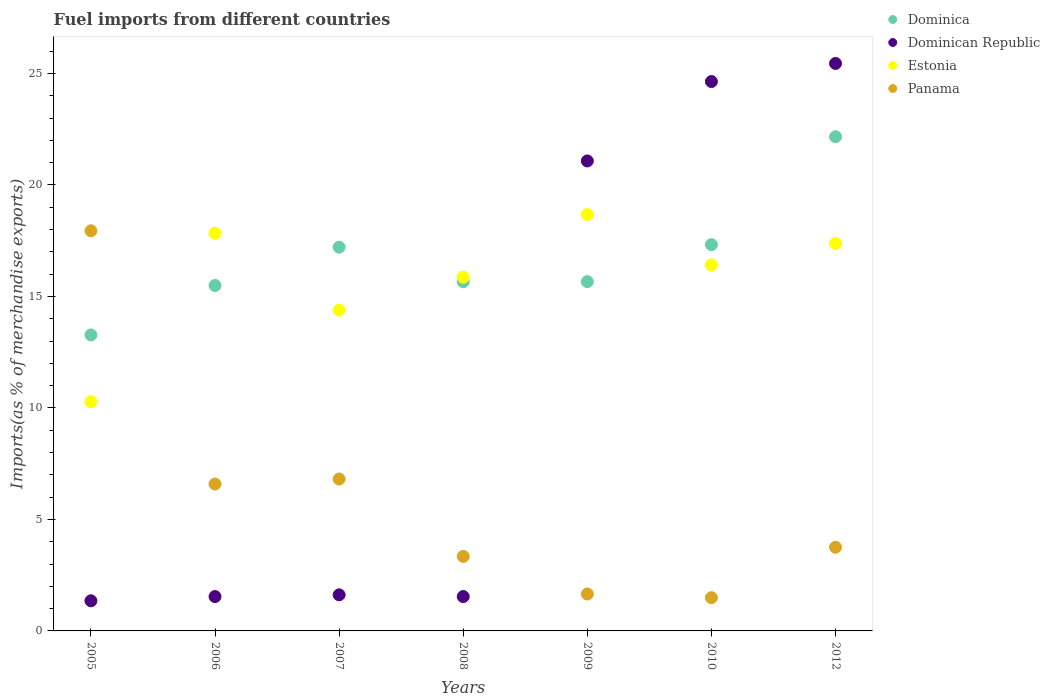How many different coloured dotlines are there?
Keep it short and to the point. 4. Is the number of dotlines equal to the number of legend labels?
Your answer should be very brief. Yes. What is the percentage of imports to different countries in Panama in 2008?
Your answer should be compact. 3.34. Across all years, what is the maximum percentage of imports to different countries in Dominican Republic?
Keep it short and to the point. 25.45. Across all years, what is the minimum percentage of imports to different countries in Panama?
Ensure brevity in your answer.  1.49. In which year was the percentage of imports to different countries in Dominica maximum?
Make the answer very short. 2012. What is the total percentage of imports to different countries in Panama in the graph?
Offer a terse response. 41.58. What is the difference between the percentage of imports to different countries in Dominican Republic in 2009 and that in 2012?
Offer a very short reply. -4.37. What is the difference between the percentage of imports to different countries in Dominica in 2006 and the percentage of imports to different countries in Estonia in 2008?
Your answer should be very brief. -0.37. What is the average percentage of imports to different countries in Estonia per year?
Provide a succinct answer. 15.83. In the year 2009, what is the difference between the percentage of imports to different countries in Panama and percentage of imports to different countries in Dominican Republic?
Your response must be concise. -19.42. In how many years, is the percentage of imports to different countries in Panama greater than 1 %?
Your answer should be compact. 7. What is the ratio of the percentage of imports to different countries in Panama in 2005 to that in 2009?
Offer a very short reply. 10.84. Is the percentage of imports to different countries in Estonia in 2009 less than that in 2012?
Offer a very short reply. No. What is the difference between the highest and the second highest percentage of imports to different countries in Dominican Republic?
Offer a very short reply. 0.81. What is the difference between the highest and the lowest percentage of imports to different countries in Dominican Republic?
Your response must be concise. 24.1. Is it the case that in every year, the sum of the percentage of imports to different countries in Dominica and percentage of imports to different countries in Panama  is greater than the percentage of imports to different countries in Estonia?
Keep it short and to the point. No. Is the percentage of imports to different countries in Estonia strictly greater than the percentage of imports to different countries in Dominican Republic over the years?
Make the answer very short. No. How many dotlines are there?
Provide a succinct answer. 4. How many years are there in the graph?
Your answer should be very brief. 7. What is the difference between two consecutive major ticks on the Y-axis?
Your answer should be very brief. 5. Does the graph contain any zero values?
Your response must be concise. No. Does the graph contain grids?
Your response must be concise. No. How are the legend labels stacked?
Provide a short and direct response. Vertical. What is the title of the graph?
Your response must be concise. Fuel imports from different countries. What is the label or title of the X-axis?
Provide a short and direct response. Years. What is the label or title of the Y-axis?
Your answer should be very brief. Imports(as % of merchandise exports). What is the Imports(as % of merchandise exports) in Dominica in 2005?
Offer a terse response. 13.27. What is the Imports(as % of merchandise exports) in Dominican Republic in 2005?
Offer a very short reply. 1.35. What is the Imports(as % of merchandise exports) in Estonia in 2005?
Make the answer very short. 10.28. What is the Imports(as % of merchandise exports) in Panama in 2005?
Your answer should be compact. 17.94. What is the Imports(as % of merchandise exports) in Dominica in 2006?
Ensure brevity in your answer.  15.49. What is the Imports(as % of merchandise exports) in Dominican Republic in 2006?
Provide a short and direct response. 1.54. What is the Imports(as % of merchandise exports) of Estonia in 2006?
Provide a succinct answer. 17.83. What is the Imports(as % of merchandise exports) in Panama in 2006?
Make the answer very short. 6.59. What is the Imports(as % of merchandise exports) in Dominica in 2007?
Make the answer very short. 17.21. What is the Imports(as % of merchandise exports) in Dominican Republic in 2007?
Your answer should be very brief. 1.62. What is the Imports(as % of merchandise exports) in Estonia in 2007?
Make the answer very short. 14.39. What is the Imports(as % of merchandise exports) in Panama in 2007?
Offer a very short reply. 6.81. What is the Imports(as % of merchandise exports) of Dominica in 2008?
Offer a terse response. 15.66. What is the Imports(as % of merchandise exports) in Dominican Republic in 2008?
Offer a terse response. 1.54. What is the Imports(as % of merchandise exports) in Estonia in 2008?
Provide a succinct answer. 15.86. What is the Imports(as % of merchandise exports) of Panama in 2008?
Offer a terse response. 3.34. What is the Imports(as % of merchandise exports) in Dominica in 2009?
Ensure brevity in your answer.  15.66. What is the Imports(as % of merchandise exports) in Dominican Republic in 2009?
Ensure brevity in your answer.  21.08. What is the Imports(as % of merchandise exports) in Estonia in 2009?
Provide a short and direct response. 18.67. What is the Imports(as % of merchandise exports) of Panama in 2009?
Give a very brief answer. 1.66. What is the Imports(as % of merchandise exports) of Dominica in 2010?
Your answer should be compact. 17.32. What is the Imports(as % of merchandise exports) of Dominican Republic in 2010?
Your answer should be very brief. 24.64. What is the Imports(as % of merchandise exports) of Estonia in 2010?
Provide a succinct answer. 16.41. What is the Imports(as % of merchandise exports) of Panama in 2010?
Provide a short and direct response. 1.49. What is the Imports(as % of merchandise exports) of Dominica in 2012?
Give a very brief answer. 22.16. What is the Imports(as % of merchandise exports) in Dominican Republic in 2012?
Your answer should be compact. 25.45. What is the Imports(as % of merchandise exports) in Estonia in 2012?
Give a very brief answer. 17.37. What is the Imports(as % of merchandise exports) in Panama in 2012?
Make the answer very short. 3.75. Across all years, what is the maximum Imports(as % of merchandise exports) of Dominica?
Keep it short and to the point. 22.16. Across all years, what is the maximum Imports(as % of merchandise exports) of Dominican Republic?
Your response must be concise. 25.45. Across all years, what is the maximum Imports(as % of merchandise exports) of Estonia?
Provide a succinct answer. 18.67. Across all years, what is the maximum Imports(as % of merchandise exports) in Panama?
Provide a short and direct response. 17.94. Across all years, what is the minimum Imports(as % of merchandise exports) in Dominica?
Make the answer very short. 13.27. Across all years, what is the minimum Imports(as % of merchandise exports) of Dominican Republic?
Offer a terse response. 1.35. Across all years, what is the minimum Imports(as % of merchandise exports) in Estonia?
Your answer should be compact. 10.28. Across all years, what is the minimum Imports(as % of merchandise exports) in Panama?
Offer a terse response. 1.49. What is the total Imports(as % of merchandise exports) in Dominica in the graph?
Give a very brief answer. 116.78. What is the total Imports(as % of merchandise exports) in Dominican Republic in the graph?
Ensure brevity in your answer.  77.21. What is the total Imports(as % of merchandise exports) of Estonia in the graph?
Your answer should be very brief. 110.82. What is the total Imports(as % of merchandise exports) of Panama in the graph?
Your answer should be compact. 41.58. What is the difference between the Imports(as % of merchandise exports) in Dominica in 2005 and that in 2006?
Provide a succinct answer. -2.22. What is the difference between the Imports(as % of merchandise exports) of Dominican Republic in 2005 and that in 2006?
Provide a succinct answer. -0.19. What is the difference between the Imports(as % of merchandise exports) in Estonia in 2005 and that in 2006?
Your answer should be very brief. -7.55. What is the difference between the Imports(as % of merchandise exports) of Panama in 2005 and that in 2006?
Your answer should be very brief. 11.36. What is the difference between the Imports(as % of merchandise exports) of Dominica in 2005 and that in 2007?
Provide a short and direct response. -3.93. What is the difference between the Imports(as % of merchandise exports) in Dominican Republic in 2005 and that in 2007?
Keep it short and to the point. -0.27. What is the difference between the Imports(as % of merchandise exports) in Estonia in 2005 and that in 2007?
Your response must be concise. -4.11. What is the difference between the Imports(as % of merchandise exports) in Panama in 2005 and that in 2007?
Your answer should be compact. 11.13. What is the difference between the Imports(as % of merchandise exports) of Dominica in 2005 and that in 2008?
Give a very brief answer. -2.39. What is the difference between the Imports(as % of merchandise exports) in Dominican Republic in 2005 and that in 2008?
Make the answer very short. -0.19. What is the difference between the Imports(as % of merchandise exports) of Estonia in 2005 and that in 2008?
Offer a terse response. -5.58. What is the difference between the Imports(as % of merchandise exports) in Panama in 2005 and that in 2008?
Your answer should be very brief. 14.6. What is the difference between the Imports(as % of merchandise exports) in Dominica in 2005 and that in 2009?
Your answer should be compact. -2.39. What is the difference between the Imports(as % of merchandise exports) of Dominican Republic in 2005 and that in 2009?
Give a very brief answer. -19.72. What is the difference between the Imports(as % of merchandise exports) of Estonia in 2005 and that in 2009?
Provide a short and direct response. -8.39. What is the difference between the Imports(as % of merchandise exports) in Panama in 2005 and that in 2009?
Offer a very short reply. 16.29. What is the difference between the Imports(as % of merchandise exports) of Dominica in 2005 and that in 2010?
Provide a succinct answer. -4.05. What is the difference between the Imports(as % of merchandise exports) in Dominican Republic in 2005 and that in 2010?
Provide a succinct answer. -23.28. What is the difference between the Imports(as % of merchandise exports) of Estonia in 2005 and that in 2010?
Make the answer very short. -6.13. What is the difference between the Imports(as % of merchandise exports) of Panama in 2005 and that in 2010?
Offer a terse response. 16.45. What is the difference between the Imports(as % of merchandise exports) in Dominica in 2005 and that in 2012?
Your response must be concise. -8.89. What is the difference between the Imports(as % of merchandise exports) in Dominican Republic in 2005 and that in 2012?
Make the answer very short. -24.1. What is the difference between the Imports(as % of merchandise exports) of Estonia in 2005 and that in 2012?
Give a very brief answer. -7.09. What is the difference between the Imports(as % of merchandise exports) in Panama in 2005 and that in 2012?
Provide a short and direct response. 14.19. What is the difference between the Imports(as % of merchandise exports) in Dominica in 2006 and that in 2007?
Provide a succinct answer. -1.72. What is the difference between the Imports(as % of merchandise exports) in Dominican Republic in 2006 and that in 2007?
Make the answer very short. -0.08. What is the difference between the Imports(as % of merchandise exports) of Estonia in 2006 and that in 2007?
Keep it short and to the point. 3.45. What is the difference between the Imports(as % of merchandise exports) of Panama in 2006 and that in 2007?
Provide a short and direct response. -0.23. What is the difference between the Imports(as % of merchandise exports) in Dominica in 2006 and that in 2008?
Provide a short and direct response. -0.17. What is the difference between the Imports(as % of merchandise exports) of Dominican Republic in 2006 and that in 2008?
Provide a succinct answer. -0. What is the difference between the Imports(as % of merchandise exports) of Estonia in 2006 and that in 2008?
Provide a short and direct response. 1.97. What is the difference between the Imports(as % of merchandise exports) in Panama in 2006 and that in 2008?
Your answer should be compact. 3.25. What is the difference between the Imports(as % of merchandise exports) in Dominica in 2006 and that in 2009?
Ensure brevity in your answer.  -0.17. What is the difference between the Imports(as % of merchandise exports) in Dominican Republic in 2006 and that in 2009?
Provide a short and direct response. -19.53. What is the difference between the Imports(as % of merchandise exports) in Estonia in 2006 and that in 2009?
Ensure brevity in your answer.  -0.84. What is the difference between the Imports(as % of merchandise exports) of Panama in 2006 and that in 2009?
Make the answer very short. 4.93. What is the difference between the Imports(as % of merchandise exports) of Dominica in 2006 and that in 2010?
Offer a very short reply. -1.83. What is the difference between the Imports(as % of merchandise exports) in Dominican Republic in 2006 and that in 2010?
Offer a terse response. -23.09. What is the difference between the Imports(as % of merchandise exports) in Estonia in 2006 and that in 2010?
Provide a succinct answer. 1.42. What is the difference between the Imports(as % of merchandise exports) in Panama in 2006 and that in 2010?
Give a very brief answer. 5.1. What is the difference between the Imports(as % of merchandise exports) in Dominica in 2006 and that in 2012?
Ensure brevity in your answer.  -6.67. What is the difference between the Imports(as % of merchandise exports) in Dominican Republic in 2006 and that in 2012?
Offer a very short reply. -23.91. What is the difference between the Imports(as % of merchandise exports) in Estonia in 2006 and that in 2012?
Keep it short and to the point. 0.46. What is the difference between the Imports(as % of merchandise exports) of Panama in 2006 and that in 2012?
Make the answer very short. 2.84. What is the difference between the Imports(as % of merchandise exports) of Dominica in 2007 and that in 2008?
Ensure brevity in your answer.  1.55. What is the difference between the Imports(as % of merchandise exports) of Dominican Republic in 2007 and that in 2008?
Your answer should be very brief. 0.08. What is the difference between the Imports(as % of merchandise exports) of Estonia in 2007 and that in 2008?
Make the answer very short. -1.48. What is the difference between the Imports(as % of merchandise exports) in Panama in 2007 and that in 2008?
Ensure brevity in your answer.  3.47. What is the difference between the Imports(as % of merchandise exports) in Dominica in 2007 and that in 2009?
Provide a short and direct response. 1.54. What is the difference between the Imports(as % of merchandise exports) in Dominican Republic in 2007 and that in 2009?
Give a very brief answer. -19.46. What is the difference between the Imports(as % of merchandise exports) in Estonia in 2007 and that in 2009?
Offer a terse response. -4.29. What is the difference between the Imports(as % of merchandise exports) of Panama in 2007 and that in 2009?
Make the answer very short. 5.16. What is the difference between the Imports(as % of merchandise exports) of Dominica in 2007 and that in 2010?
Your answer should be compact. -0.11. What is the difference between the Imports(as % of merchandise exports) of Dominican Republic in 2007 and that in 2010?
Make the answer very short. -23.02. What is the difference between the Imports(as % of merchandise exports) in Estonia in 2007 and that in 2010?
Your answer should be very brief. -2.03. What is the difference between the Imports(as % of merchandise exports) in Panama in 2007 and that in 2010?
Provide a short and direct response. 5.32. What is the difference between the Imports(as % of merchandise exports) of Dominica in 2007 and that in 2012?
Your answer should be compact. -4.95. What is the difference between the Imports(as % of merchandise exports) of Dominican Republic in 2007 and that in 2012?
Your answer should be compact. -23.83. What is the difference between the Imports(as % of merchandise exports) of Estonia in 2007 and that in 2012?
Offer a very short reply. -2.98. What is the difference between the Imports(as % of merchandise exports) of Panama in 2007 and that in 2012?
Make the answer very short. 3.06. What is the difference between the Imports(as % of merchandise exports) of Dominica in 2008 and that in 2009?
Provide a succinct answer. -0. What is the difference between the Imports(as % of merchandise exports) in Dominican Republic in 2008 and that in 2009?
Your answer should be compact. -19.53. What is the difference between the Imports(as % of merchandise exports) in Estonia in 2008 and that in 2009?
Your answer should be compact. -2.81. What is the difference between the Imports(as % of merchandise exports) in Panama in 2008 and that in 2009?
Offer a very short reply. 1.69. What is the difference between the Imports(as % of merchandise exports) in Dominica in 2008 and that in 2010?
Offer a very short reply. -1.66. What is the difference between the Imports(as % of merchandise exports) of Dominican Republic in 2008 and that in 2010?
Provide a succinct answer. -23.09. What is the difference between the Imports(as % of merchandise exports) in Estonia in 2008 and that in 2010?
Your response must be concise. -0.55. What is the difference between the Imports(as % of merchandise exports) in Panama in 2008 and that in 2010?
Provide a succinct answer. 1.85. What is the difference between the Imports(as % of merchandise exports) of Dominica in 2008 and that in 2012?
Provide a succinct answer. -6.5. What is the difference between the Imports(as % of merchandise exports) of Dominican Republic in 2008 and that in 2012?
Offer a very short reply. -23.91. What is the difference between the Imports(as % of merchandise exports) of Estonia in 2008 and that in 2012?
Provide a short and direct response. -1.51. What is the difference between the Imports(as % of merchandise exports) of Panama in 2008 and that in 2012?
Your answer should be compact. -0.41. What is the difference between the Imports(as % of merchandise exports) in Dominica in 2009 and that in 2010?
Keep it short and to the point. -1.66. What is the difference between the Imports(as % of merchandise exports) of Dominican Republic in 2009 and that in 2010?
Make the answer very short. -3.56. What is the difference between the Imports(as % of merchandise exports) of Estonia in 2009 and that in 2010?
Your answer should be compact. 2.26. What is the difference between the Imports(as % of merchandise exports) in Panama in 2009 and that in 2010?
Ensure brevity in your answer.  0.16. What is the difference between the Imports(as % of merchandise exports) of Dominica in 2009 and that in 2012?
Provide a succinct answer. -6.5. What is the difference between the Imports(as % of merchandise exports) of Dominican Republic in 2009 and that in 2012?
Your answer should be compact. -4.37. What is the difference between the Imports(as % of merchandise exports) in Estonia in 2009 and that in 2012?
Ensure brevity in your answer.  1.3. What is the difference between the Imports(as % of merchandise exports) of Panama in 2009 and that in 2012?
Ensure brevity in your answer.  -2.1. What is the difference between the Imports(as % of merchandise exports) in Dominica in 2010 and that in 2012?
Make the answer very short. -4.84. What is the difference between the Imports(as % of merchandise exports) in Dominican Republic in 2010 and that in 2012?
Ensure brevity in your answer.  -0.81. What is the difference between the Imports(as % of merchandise exports) of Estonia in 2010 and that in 2012?
Make the answer very short. -0.96. What is the difference between the Imports(as % of merchandise exports) of Panama in 2010 and that in 2012?
Your answer should be compact. -2.26. What is the difference between the Imports(as % of merchandise exports) of Dominica in 2005 and the Imports(as % of merchandise exports) of Dominican Republic in 2006?
Offer a terse response. 11.73. What is the difference between the Imports(as % of merchandise exports) in Dominica in 2005 and the Imports(as % of merchandise exports) in Estonia in 2006?
Your answer should be compact. -4.56. What is the difference between the Imports(as % of merchandise exports) in Dominica in 2005 and the Imports(as % of merchandise exports) in Panama in 2006?
Keep it short and to the point. 6.69. What is the difference between the Imports(as % of merchandise exports) of Dominican Republic in 2005 and the Imports(as % of merchandise exports) of Estonia in 2006?
Ensure brevity in your answer.  -16.48. What is the difference between the Imports(as % of merchandise exports) in Dominican Republic in 2005 and the Imports(as % of merchandise exports) in Panama in 2006?
Your answer should be very brief. -5.24. What is the difference between the Imports(as % of merchandise exports) in Estonia in 2005 and the Imports(as % of merchandise exports) in Panama in 2006?
Offer a very short reply. 3.69. What is the difference between the Imports(as % of merchandise exports) of Dominica in 2005 and the Imports(as % of merchandise exports) of Dominican Republic in 2007?
Your answer should be very brief. 11.65. What is the difference between the Imports(as % of merchandise exports) of Dominica in 2005 and the Imports(as % of merchandise exports) of Estonia in 2007?
Keep it short and to the point. -1.11. What is the difference between the Imports(as % of merchandise exports) of Dominica in 2005 and the Imports(as % of merchandise exports) of Panama in 2007?
Make the answer very short. 6.46. What is the difference between the Imports(as % of merchandise exports) of Dominican Republic in 2005 and the Imports(as % of merchandise exports) of Estonia in 2007?
Provide a succinct answer. -13.04. What is the difference between the Imports(as % of merchandise exports) of Dominican Republic in 2005 and the Imports(as % of merchandise exports) of Panama in 2007?
Offer a very short reply. -5.46. What is the difference between the Imports(as % of merchandise exports) of Estonia in 2005 and the Imports(as % of merchandise exports) of Panama in 2007?
Provide a succinct answer. 3.47. What is the difference between the Imports(as % of merchandise exports) of Dominica in 2005 and the Imports(as % of merchandise exports) of Dominican Republic in 2008?
Provide a short and direct response. 11.73. What is the difference between the Imports(as % of merchandise exports) in Dominica in 2005 and the Imports(as % of merchandise exports) in Estonia in 2008?
Your response must be concise. -2.59. What is the difference between the Imports(as % of merchandise exports) in Dominica in 2005 and the Imports(as % of merchandise exports) in Panama in 2008?
Ensure brevity in your answer.  9.93. What is the difference between the Imports(as % of merchandise exports) in Dominican Republic in 2005 and the Imports(as % of merchandise exports) in Estonia in 2008?
Make the answer very short. -14.51. What is the difference between the Imports(as % of merchandise exports) in Dominican Republic in 2005 and the Imports(as % of merchandise exports) in Panama in 2008?
Your response must be concise. -1.99. What is the difference between the Imports(as % of merchandise exports) of Estonia in 2005 and the Imports(as % of merchandise exports) of Panama in 2008?
Provide a succinct answer. 6.94. What is the difference between the Imports(as % of merchandise exports) in Dominica in 2005 and the Imports(as % of merchandise exports) in Dominican Republic in 2009?
Provide a short and direct response. -7.8. What is the difference between the Imports(as % of merchandise exports) in Dominica in 2005 and the Imports(as % of merchandise exports) in Estonia in 2009?
Give a very brief answer. -5.4. What is the difference between the Imports(as % of merchandise exports) in Dominica in 2005 and the Imports(as % of merchandise exports) in Panama in 2009?
Your answer should be compact. 11.62. What is the difference between the Imports(as % of merchandise exports) in Dominican Republic in 2005 and the Imports(as % of merchandise exports) in Estonia in 2009?
Your answer should be compact. -17.32. What is the difference between the Imports(as % of merchandise exports) of Dominican Republic in 2005 and the Imports(as % of merchandise exports) of Panama in 2009?
Your response must be concise. -0.3. What is the difference between the Imports(as % of merchandise exports) of Estonia in 2005 and the Imports(as % of merchandise exports) of Panama in 2009?
Provide a succinct answer. 8.63. What is the difference between the Imports(as % of merchandise exports) of Dominica in 2005 and the Imports(as % of merchandise exports) of Dominican Republic in 2010?
Ensure brevity in your answer.  -11.36. What is the difference between the Imports(as % of merchandise exports) in Dominica in 2005 and the Imports(as % of merchandise exports) in Estonia in 2010?
Provide a short and direct response. -3.14. What is the difference between the Imports(as % of merchandise exports) of Dominica in 2005 and the Imports(as % of merchandise exports) of Panama in 2010?
Provide a succinct answer. 11.78. What is the difference between the Imports(as % of merchandise exports) in Dominican Republic in 2005 and the Imports(as % of merchandise exports) in Estonia in 2010?
Ensure brevity in your answer.  -15.06. What is the difference between the Imports(as % of merchandise exports) in Dominican Republic in 2005 and the Imports(as % of merchandise exports) in Panama in 2010?
Provide a succinct answer. -0.14. What is the difference between the Imports(as % of merchandise exports) in Estonia in 2005 and the Imports(as % of merchandise exports) in Panama in 2010?
Give a very brief answer. 8.79. What is the difference between the Imports(as % of merchandise exports) in Dominica in 2005 and the Imports(as % of merchandise exports) in Dominican Republic in 2012?
Offer a terse response. -12.17. What is the difference between the Imports(as % of merchandise exports) of Dominica in 2005 and the Imports(as % of merchandise exports) of Estonia in 2012?
Keep it short and to the point. -4.1. What is the difference between the Imports(as % of merchandise exports) in Dominica in 2005 and the Imports(as % of merchandise exports) in Panama in 2012?
Your response must be concise. 9.52. What is the difference between the Imports(as % of merchandise exports) in Dominican Republic in 2005 and the Imports(as % of merchandise exports) in Estonia in 2012?
Your answer should be very brief. -16.02. What is the difference between the Imports(as % of merchandise exports) of Dominican Republic in 2005 and the Imports(as % of merchandise exports) of Panama in 2012?
Provide a short and direct response. -2.4. What is the difference between the Imports(as % of merchandise exports) in Estonia in 2005 and the Imports(as % of merchandise exports) in Panama in 2012?
Keep it short and to the point. 6.53. What is the difference between the Imports(as % of merchandise exports) of Dominica in 2006 and the Imports(as % of merchandise exports) of Dominican Republic in 2007?
Provide a succinct answer. 13.87. What is the difference between the Imports(as % of merchandise exports) of Dominica in 2006 and the Imports(as % of merchandise exports) of Estonia in 2007?
Ensure brevity in your answer.  1.1. What is the difference between the Imports(as % of merchandise exports) of Dominica in 2006 and the Imports(as % of merchandise exports) of Panama in 2007?
Your answer should be compact. 8.68. What is the difference between the Imports(as % of merchandise exports) of Dominican Republic in 2006 and the Imports(as % of merchandise exports) of Estonia in 2007?
Ensure brevity in your answer.  -12.85. What is the difference between the Imports(as % of merchandise exports) in Dominican Republic in 2006 and the Imports(as % of merchandise exports) in Panama in 2007?
Keep it short and to the point. -5.27. What is the difference between the Imports(as % of merchandise exports) of Estonia in 2006 and the Imports(as % of merchandise exports) of Panama in 2007?
Give a very brief answer. 11.02. What is the difference between the Imports(as % of merchandise exports) in Dominica in 2006 and the Imports(as % of merchandise exports) in Dominican Republic in 2008?
Your response must be concise. 13.95. What is the difference between the Imports(as % of merchandise exports) in Dominica in 2006 and the Imports(as % of merchandise exports) in Estonia in 2008?
Your answer should be compact. -0.37. What is the difference between the Imports(as % of merchandise exports) of Dominica in 2006 and the Imports(as % of merchandise exports) of Panama in 2008?
Your answer should be very brief. 12.15. What is the difference between the Imports(as % of merchandise exports) in Dominican Republic in 2006 and the Imports(as % of merchandise exports) in Estonia in 2008?
Give a very brief answer. -14.32. What is the difference between the Imports(as % of merchandise exports) in Dominican Republic in 2006 and the Imports(as % of merchandise exports) in Panama in 2008?
Give a very brief answer. -1.8. What is the difference between the Imports(as % of merchandise exports) in Estonia in 2006 and the Imports(as % of merchandise exports) in Panama in 2008?
Your answer should be compact. 14.49. What is the difference between the Imports(as % of merchandise exports) in Dominica in 2006 and the Imports(as % of merchandise exports) in Dominican Republic in 2009?
Provide a succinct answer. -5.59. What is the difference between the Imports(as % of merchandise exports) of Dominica in 2006 and the Imports(as % of merchandise exports) of Estonia in 2009?
Offer a terse response. -3.18. What is the difference between the Imports(as % of merchandise exports) in Dominica in 2006 and the Imports(as % of merchandise exports) in Panama in 2009?
Offer a very short reply. 13.83. What is the difference between the Imports(as % of merchandise exports) in Dominican Republic in 2006 and the Imports(as % of merchandise exports) in Estonia in 2009?
Give a very brief answer. -17.13. What is the difference between the Imports(as % of merchandise exports) in Dominican Republic in 2006 and the Imports(as % of merchandise exports) in Panama in 2009?
Your answer should be very brief. -0.12. What is the difference between the Imports(as % of merchandise exports) in Estonia in 2006 and the Imports(as % of merchandise exports) in Panama in 2009?
Keep it short and to the point. 16.18. What is the difference between the Imports(as % of merchandise exports) in Dominica in 2006 and the Imports(as % of merchandise exports) in Dominican Republic in 2010?
Provide a succinct answer. -9.15. What is the difference between the Imports(as % of merchandise exports) of Dominica in 2006 and the Imports(as % of merchandise exports) of Estonia in 2010?
Keep it short and to the point. -0.92. What is the difference between the Imports(as % of merchandise exports) of Dominica in 2006 and the Imports(as % of merchandise exports) of Panama in 2010?
Make the answer very short. 14. What is the difference between the Imports(as % of merchandise exports) of Dominican Republic in 2006 and the Imports(as % of merchandise exports) of Estonia in 2010?
Keep it short and to the point. -14.87. What is the difference between the Imports(as % of merchandise exports) in Dominican Republic in 2006 and the Imports(as % of merchandise exports) in Panama in 2010?
Your response must be concise. 0.05. What is the difference between the Imports(as % of merchandise exports) of Estonia in 2006 and the Imports(as % of merchandise exports) of Panama in 2010?
Your answer should be compact. 16.34. What is the difference between the Imports(as % of merchandise exports) of Dominica in 2006 and the Imports(as % of merchandise exports) of Dominican Republic in 2012?
Your answer should be very brief. -9.96. What is the difference between the Imports(as % of merchandise exports) of Dominica in 2006 and the Imports(as % of merchandise exports) of Estonia in 2012?
Offer a very short reply. -1.88. What is the difference between the Imports(as % of merchandise exports) of Dominica in 2006 and the Imports(as % of merchandise exports) of Panama in 2012?
Ensure brevity in your answer.  11.74. What is the difference between the Imports(as % of merchandise exports) in Dominican Republic in 2006 and the Imports(as % of merchandise exports) in Estonia in 2012?
Make the answer very short. -15.83. What is the difference between the Imports(as % of merchandise exports) of Dominican Republic in 2006 and the Imports(as % of merchandise exports) of Panama in 2012?
Offer a terse response. -2.21. What is the difference between the Imports(as % of merchandise exports) in Estonia in 2006 and the Imports(as % of merchandise exports) in Panama in 2012?
Ensure brevity in your answer.  14.08. What is the difference between the Imports(as % of merchandise exports) of Dominica in 2007 and the Imports(as % of merchandise exports) of Dominican Republic in 2008?
Provide a short and direct response. 15.67. What is the difference between the Imports(as % of merchandise exports) in Dominica in 2007 and the Imports(as % of merchandise exports) in Estonia in 2008?
Make the answer very short. 1.35. What is the difference between the Imports(as % of merchandise exports) in Dominica in 2007 and the Imports(as % of merchandise exports) in Panama in 2008?
Give a very brief answer. 13.87. What is the difference between the Imports(as % of merchandise exports) of Dominican Republic in 2007 and the Imports(as % of merchandise exports) of Estonia in 2008?
Your answer should be very brief. -14.24. What is the difference between the Imports(as % of merchandise exports) of Dominican Republic in 2007 and the Imports(as % of merchandise exports) of Panama in 2008?
Provide a succinct answer. -1.72. What is the difference between the Imports(as % of merchandise exports) in Estonia in 2007 and the Imports(as % of merchandise exports) in Panama in 2008?
Offer a very short reply. 11.05. What is the difference between the Imports(as % of merchandise exports) in Dominica in 2007 and the Imports(as % of merchandise exports) in Dominican Republic in 2009?
Provide a short and direct response. -3.87. What is the difference between the Imports(as % of merchandise exports) of Dominica in 2007 and the Imports(as % of merchandise exports) of Estonia in 2009?
Your answer should be very brief. -1.47. What is the difference between the Imports(as % of merchandise exports) of Dominica in 2007 and the Imports(as % of merchandise exports) of Panama in 2009?
Your answer should be very brief. 15.55. What is the difference between the Imports(as % of merchandise exports) in Dominican Republic in 2007 and the Imports(as % of merchandise exports) in Estonia in 2009?
Your answer should be compact. -17.06. What is the difference between the Imports(as % of merchandise exports) in Dominican Republic in 2007 and the Imports(as % of merchandise exports) in Panama in 2009?
Your answer should be very brief. -0.04. What is the difference between the Imports(as % of merchandise exports) of Estonia in 2007 and the Imports(as % of merchandise exports) of Panama in 2009?
Ensure brevity in your answer.  12.73. What is the difference between the Imports(as % of merchandise exports) in Dominica in 2007 and the Imports(as % of merchandise exports) in Dominican Republic in 2010?
Offer a very short reply. -7.43. What is the difference between the Imports(as % of merchandise exports) of Dominica in 2007 and the Imports(as % of merchandise exports) of Estonia in 2010?
Make the answer very short. 0.79. What is the difference between the Imports(as % of merchandise exports) of Dominica in 2007 and the Imports(as % of merchandise exports) of Panama in 2010?
Provide a short and direct response. 15.72. What is the difference between the Imports(as % of merchandise exports) in Dominican Republic in 2007 and the Imports(as % of merchandise exports) in Estonia in 2010?
Ensure brevity in your answer.  -14.8. What is the difference between the Imports(as % of merchandise exports) of Dominican Republic in 2007 and the Imports(as % of merchandise exports) of Panama in 2010?
Give a very brief answer. 0.13. What is the difference between the Imports(as % of merchandise exports) of Estonia in 2007 and the Imports(as % of merchandise exports) of Panama in 2010?
Offer a very short reply. 12.9. What is the difference between the Imports(as % of merchandise exports) of Dominica in 2007 and the Imports(as % of merchandise exports) of Dominican Republic in 2012?
Ensure brevity in your answer.  -8.24. What is the difference between the Imports(as % of merchandise exports) in Dominica in 2007 and the Imports(as % of merchandise exports) in Estonia in 2012?
Provide a succinct answer. -0.16. What is the difference between the Imports(as % of merchandise exports) in Dominica in 2007 and the Imports(as % of merchandise exports) in Panama in 2012?
Keep it short and to the point. 13.46. What is the difference between the Imports(as % of merchandise exports) in Dominican Republic in 2007 and the Imports(as % of merchandise exports) in Estonia in 2012?
Offer a very short reply. -15.75. What is the difference between the Imports(as % of merchandise exports) of Dominican Republic in 2007 and the Imports(as % of merchandise exports) of Panama in 2012?
Your answer should be very brief. -2.13. What is the difference between the Imports(as % of merchandise exports) of Estonia in 2007 and the Imports(as % of merchandise exports) of Panama in 2012?
Provide a short and direct response. 10.64. What is the difference between the Imports(as % of merchandise exports) of Dominica in 2008 and the Imports(as % of merchandise exports) of Dominican Republic in 2009?
Provide a succinct answer. -5.42. What is the difference between the Imports(as % of merchandise exports) in Dominica in 2008 and the Imports(as % of merchandise exports) in Estonia in 2009?
Provide a short and direct response. -3.01. What is the difference between the Imports(as % of merchandise exports) of Dominica in 2008 and the Imports(as % of merchandise exports) of Panama in 2009?
Your answer should be compact. 14. What is the difference between the Imports(as % of merchandise exports) in Dominican Republic in 2008 and the Imports(as % of merchandise exports) in Estonia in 2009?
Give a very brief answer. -17.13. What is the difference between the Imports(as % of merchandise exports) of Dominican Republic in 2008 and the Imports(as % of merchandise exports) of Panama in 2009?
Provide a succinct answer. -0.11. What is the difference between the Imports(as % of merchandise exports) of Estonia in 2008 and the Imports(as % of merchandise exports) of Panama in 2009?
Your response must be concise. 14.21. What is the difference between the Imports(as % of merchandise exports) of Dominica in 2008 and the Imports(as % of merchandise exports) of Dominican Republic in 2010?
Your answer should be very brief. -8.98. What is the difference between the Imports(as % of merchandise exports) of Dominica in 2008 and the Imports(as % of merchandise exports) of Estonia in 2010?
Offer a very short reply. -0.75. What is the difference between the Imports(as % of merchandise exports) of Dominica in 2008 and the Imports(as % of merchandise exports) of Panama in 2010?
Your answer should be compact. 14.17. What is the difference between the Imports(as % of merchandise exports) of Dominican Republic in 2008 and the Imports(as % of merchandise exports) of Estonia in 2010?
Your answer should be very brief. -14.87. What is the difference between the Imports(as % of merchandise exports) in Dominican Republic in 2008 and the Imports(as % of merchandise exports) in Panama in 2010?
Give a very brief answer. 0.05. What is the difference between the Imports(as % of merchandise exports) in Estonia in 2008 and the Imports(as % of merchandise exports) in Panama in 2010?
Your answer should be very brief. 14.37. What is the difference between the Imports(as % of merchandise exports) of Dominica in 2008 and the Imports(as % of merchandise exports) of Dominican Republic in 2012?
Give a very brief answer. -9.79. What is the difference between the Imports(as % of merchandise exports) of Dominica in 2008 and the Imports(as % of merchandise exports) of Estonia in 2012?
Give a very brief answer. -1.71. What is the difference between the Imports(as % of merchandise exports) in Dominica in 2008 and the Imports(as % of merchandise exports) in Panama in 2012?
Give a very brief answer. 11.91. What is the difference between the Imports(as % of merchandise exports) of Dominican Republic in 2008 and the Imports(as % of merchandise exports) of Estonia in 2012?
Your answer should be compact. -15.83. What is the difference between the Imports(as % of merchandise exports) of Dominican Republic in 2008 and the Imports(as % of merchandise exports) of Panama in 2012?
Make the answer very short. -2.21. What is the difference between the Imports(as % of merchandise exports) in Estonia in 2008 and the Imports(as % of merchandise exports) in Panama in 2012?
Your answer should be compact. 12.11. What is the difference between the Imports(as % of merchandise exports) of Dominica in 2009 and the Imports(as % of merchandise exports) of Dominican Republic in 2010?
Provide a succinct answer. -8.97. What is the difference between the Imports(as % of merchandise exports) in Dominica in 2009 and the Imports(as % of merchandise exports) in Estonia in 2010?
Your answer should be compact. -0.75. What is the difference between the Imports(as % of merchandise exports) of Dominica in 2009 and the Imports(as % of merchandise exports) of Panama in 2010?
Keep it short and to the point. 14.17. What is the difference between the Imports(as % of merchandise exports) in Dominican Republic in 2009 and the Imports(as % of merchandise exports) in Estonia in 2010?
Make the answer very short. 4.66. What is the difference between the Imports(as % of merchandise exports) of Dominican Republic in 2009 and the Imports(as % of merchandise exports) of Panama in 2010?
Your response must be concise. 19.58. What is the difference between the Imports(as % of merchandise exports) of Estonia in 2009 and the Imports(as % of merchandise exports) of Panama in 2010?
Offer a very short reply. 17.18. What is the difference between the Imports(as % of merchandise exports) of Dominica in 2009 and the Imports(as % of merchandise exports) of Dominican Republic in 2012?
Your answer should be compact. -9.78. What is the difference between the Imports(as % of merchandise exports) in Dominica in 2009 and the Imports(as % of merchandise exports) in Estonia in 2012?
Keep it short and to the point. -1.71. What is the difference between the Imports(as % of merchandise exports) in Dominica in 2009 and the Imports(as % of merchandise exports) in Panama in 2012?
Provide a short and direct response. 11.91. What is the difference between the Imports(as % of merchandise exports) in Dominican Republic in 2009 and the Imports(as % of merchandise exports) in Estonia in 2012?
Ensure brevity in your answer.  3.7. What is the difference between the Imports(as % of merchandise exports) in Dominican Republic in 2009 and the Imports(as % of merchandise exports) in Panama in 2012?
Keep it short and to the point. 17.32. What is the difference between the Imports(as % of merchandise exports) of Estonia in 2009 and the Imports(as % of merchandise exports) of Panama in 2012?
Offer a terse response. 14.92. What is the difference between the Imports(as % of merchandise exports) of Dominica in 2010 and the Imports(as % of merchandise exports) of Dominican Republic in 2012?
Your answer should be very brief. -8.13. What is the difference between the Imports(as % of merchandise exports) of Dominica in 2010 and the Imports(as % of merchandise exports) of Estonia in 2012?
Your answer should be compact. -0.05. What is the difference between the Imports(as % of merchandise exports) in Dominica in 2010 and the Imports(as % of merchandise exports) in Panama in 2012?
Offer a very short reply. 13.57. What is the difference between the Imports(as % of merchandise exports) of Dominican Republic in 2010 and the Imports(as % of merchandise exports) of Estonia in 2012?
Keep it short and to the point. 7.26. What is the difference between the Imports(as % of merchandise exports) of Dominican Republic in 2010 and the Imports(as % of merchandise exports) of Panama in 2012?
Your answer should be compact. 20.88. What is the difference between the Imports(as % of merchandise exports) in Estonia in 2010 and the Imports(as % of merchandise exports) in Panama in 2012?
Keep it short and to the point. 12.66. What is the average Imports(as % of merchandise exports) of Dominica per year?
Keep it short and to the point. 16.68. What is the average Imports(as % of merchandise exports) of Dominican Republic per year?
Provide a short and direct response. 11.03. What is the average Imports(as % of merchandise exports) in Estonia per year?
Give a very brief answer. 15.83. What is the average Imports(as % of merchandise exports) of Panama per year?
Give a very brief answer. 5.94. In the year 2005, what is the difference between the Imports(as % of merchandise exports) in Dominica and Imports(as % of merchandise exports) in Dominican Republic?
Your response must be concise. 11.92. In the year 2005, what is the difference between the Imports(as % of merchandise exports) in Dominica and Imports(as % of merchandise exports) in Estonia?
Provide a succinct answer. 2.99. In the year 2005, what is the difference between the Imports(as % of merchandise exports) in Dominica and Imports(as % of merchandise exports) in Panama?
Your answer should be compact. -4.67. In the year 2005, what is the difference between the Imports(as % of merchandise exports) of Dominican Republic and Imports(as % of merchandise exports) of Estonia?
Your answer should be compact. -8.93. In the year 2005, what is the difference between the Imports(as % of merchandise exports) in Dominican Republic and Imports(as % of merchandise exports) in Panama?
Your answer should be compact. -16.59. In the year 2005, what is the difference between the Imports(as % of merchandise exports) of Estonia and Imports(as % of merchandise exports) of Panama?
Offer a terse response. -7.66. In the year 2006, what is the difference between the Imports(as % of merchandise exports) of Dominica and Imports(as % of merchandise exports) of Dominican Republic?
Keep it short and to the point. 13.95. In the year 2006, what is the difference between the Imports(as % of merchandise exports) of Dominica and Imports(as % of merchandise exports) of Estonia?
Ensure brevity in your answer.  -2.34. In the year 2006, what is the difference between the Imports(as % of merchandise exports) of Dominica and Imports(as % of merchandise exports) of Panama?
Provide a succinct answer. 8.9. In the year 2006, what is the difference between the Imports(as % of merchandise exports) of Dominican Republic and Imports(as % of merchandise exports) of Estonia?
Your answer should be very brief. -16.29. In the year 2006, what is the difference between the Imports(as % of merchandise exports) in Dominican Republic and Imports(as % of merchandise exports) in Panama?
Provide a succinct answer. -5.05. In the year 2006, what is the difference between the Imports(as % of merchandise exports) in Estonia and Imports(as % of merchandise exports) in Panama?
Your answer should be very brief. 11.25. In the year 2007, what is the difference between the Imports(as % of merchandise exports) of Dominica and Imports(as % of merchandise exports) of Dominican Republic?
Make the answer very short. 15.59. In the year 2007, what is the difference between the Imports(as % of merchandise exports) of Dominica and Imports(as % of merchandise exports) of Estonia?
Your answer should be very brief. 2.82. In the year 2007, what is the difference between the Imports(as % of merchandise exports) of Dominica and Imports(as % of merchandise exports) of Panama?
Give a very brief answer. 10.4. In the year 2007, what is the difference between the Imports(as % of merchandise exports) of Dominican Republic and Imports(as % of merchandise exports) of Estonia?
Provide a succinct answer. -12.77. In the year 2007, what is the difference between the Imports(as % of merchandise exports) of Dominican Republic and Imports(as % of merchandise exports) of Panama?
Provide a succinct answer. -5.19. In the year 2007, what is the difference between the Imports(as % of merchandise exports) of Estonia and Imports(as % of merchandise exports) of Panama?
Provide a succinct answer. 7.57. In the year 2008, what is the difference between the Imports(as % of merchandise exports) of Dominica and Imports(as % of merchandise exports) of Dominican Republic?
Offer a very short reply. 14.12. In the year 2008, what is the difference between the Imports(as % of merchandise exports) of Dominica and Imports(as % of merchandise exports) of Estonia?
Your answer should be compact. -0.2. In the year 2008, what is the difference between the Imports(as % of merchandise exports) in Dominica and Imports(as % of merchandise exports) in Panama?
Give a very brief answer. 12.32. In the year 2008, what is the difference between the Imports(as % of merchandise exports) in Dominican Republic and Imports(as % of merchandise exports) in Estonia?
Your answer should be very brief. -14.32. In the year 2008, what is the difference between the Imports(as % of merchandise exports) in Estonia and Imports(as % of merchandise exports) in Panama?
Offer a terse response. 12.52. In the year 2009, what is the difference between the Imports(as % of merchandise exports) of Dominica and Imports(as % of merchandise exports) of Dominican Republic?
Keep it short and to the point. -5.41. In the year 2009, what is the difference between the Imports(as % of merchandise exports) in Dominica and Imports(as % of merchandise exports) in Estonia?
Your response must be concise. -3.01. In the year 2009, what is the difference between the Imports(as % of merchandise exports) of Dominica and Imports(as % of merchandise exports) of Panama?
Ensure brevity in your answer.  14.01. In the year 2009, what is the difference between the Imports(as % of merchandise exports) of Dominican Republic and Imports(as % of merchandise exports) of Estonia?
Provide a succinct answer. 2.4. In the year 2009, what is the difference between the Imports(as % of merchandise exports) of Dominican Republic and Imports(as % of merchandise exports) of Panama?
Ensure brevity in your answer.  19.42. In the year 2009, what is the difference between the Imports(as % of merchandise exports) of Estonia and Imports(as % of merchandise exports) of Panama?
Provide a succinct answer. 17.02. In the year 2010, what is the difference between the Imports(as % of merchandise exports) in Dominica and Imports(as % of merchandise exports) in Dominican Republic?
Offer a terse response. -7.32. In the year 2010, what is the difference between the Imports(as % of merchandise exports) in Dominica and Imports(as % of merchandise exports) in Estonia?
Provide a succinct answer. 0.91. In the year 2010, what is the difference between the Imports(as % of merchandise exports) of Dominica and Imports(as % of merchandise exports) of Panama?
Keep it short and to the point. 15.83. In the year 2010, what is the difference between the Imports(as % of merchandise exports) in Dominican Republic and Imports(as % of merchandise exports) in Estonia?
Ensure brevity in your answer.  8.22. In the year 2010, what is the difference between the Imports(as % of merchandise exports) in Dominican Republic and Imports(as % of merchandise exports) in Panama?
Give a very brief answer. 23.14. In the year 2010, what is the difference between the Imports(as % of merchandise exports) of Estonia and Imports(as % of merchandise exports) of Panama?
Your answer should be compact. 14.92. In the year 2012, what is the difference between the Imports(as % of merchandise exports) of Dominica and Imports(as % of merchandise exports) of Dominican Republic?
Your answer should be compact. -3.29. In the year 2012, what is the difference between the Imports(as % of merchandise exports) in Dominica and Imports(as % of merchandise exports) in Estonia?
Ensure brevity in your answer.  4.79. In the year 2012, what is the difference between the Imports(as % of merchandise exports) of Dominica and Imports(as % of merchandise exports) of Panama?
Your answer should be very brief. 18.41. In the year 2012, what is the difference between the Imports(as % of merchandise exports) of Dominican Republic and Imports(as % of merchandise exports) of Estonia?
Make the answer very short. 8.08. In the year 2012, what is the difference between the Imports(as % of merchandise exports) in Dominican Republic and Imports(as % of merchandise exports) in Panama?
Offer a terse response. 21.7. In the year 2012, what is the difference between the Imports(as % of merchandise exports) of Estonia and Imports(as % of merchandise exports) of Panama?
Ensure brevity in your answer.  13.62. What is the ratio of the Imports(as % of merchandise exports) of Dominica in 2005 to that in 2006?
Your response must be concise. 0.86. What is the ratio of the Imports(as % of merchandise exports) of Dominican Republic in 2005 to that in 2006?
Make the answer very short. 0.88. What is the ratio of the Imports(as % of merchandise exports) in Estonia in 2005 to that in 2006?
Your response must be concise. 0.58. What is the ratio of the Imports(as % of merchandise exports) of Panama in 2005 to that in 2006?
Offer a very short reply. 2.72. What is the ratio of the Imports(as % of merchandise exports) in Dominica in 2005 to that in 2007?
Your response must be concise. 0.77. What is the ratio of the Imports(as % of merchandise exports) in Dominican Republic in 2005 to that in 2007?
Offer a terse response. 0.83. What is the ratio of the Imports(as % of merchandise exports) of Estonia in 2005 to that in 2007?
Keep it short and to the point. 0.71. What is the ratio of the Imports(as % of merchandise exports) of Panama in 2005 to that in 2007?
Offer a very short reply. 2.63. What is the ratio of the Imports(as % of merchandise exports) in Dominica in 2005 to that in 2008?
Keep it short and to the point. 0.85. What is the ratio of the Imports(as % of merchandise exports) of Dominican Republic in 2005 to that in 2008?
Your response must be concise. 0.88. What is the ratio of the Imports(as % of merchandise exports) of Estonia in 2005 to that in 2008?
Keep it short and to the point. 0.65. What is the ratio of the Imports(as % of merchandise exports) in Panama in 2005 to that in 2008?
Give a very brief answer. 5.37. What is the ratio of the Imports(as % of merchandise exports) of Dominica in 2005 to that in 2009?
Provide a succinct answer. 0.85. What is the ratio of the Imports(as % of merchandise exports) in Dominican Republic in 2005 to that in 2009?
Keep it short and to the point. 0.06. What is the ratio of the Imports(as % of merchandise exports) in Estonia in 2005 to that in 2009?
Your answer should be very brief. 0.55. What is the ratio of the Imports(as % of merchandise exports) in Panama in 2005 to that in 2009?
Give a very brief answer. 10.84. What is the ratio of the Imports(as % of merchandise exports) of Dominica in 2005 to that in 2010?
Your answer should be compact. 0.77. What is the ratio of the Imports(as % of merchandise exports) of Dominican Republic in 2005 to that in 2010?
Your answer should be compact. 0.05. What is the ratio of the Imports(as % of merchandise exports) of Estonia in 2005 to that in 2010?
Your response must be concise. 0.63. What is the ratio of the Imports(as % of merchandise exports) in Panama in 2005 to that in 2010?
Offer a very short reply. 12.03. What is the ratio of the Imports(as % of merchandise exports) in Dominica in 2005 to that in 2012?
Provide a succinct answer. 0.6. What is the ratio of the Imports(as % of merchandise exports) of Dominican Republic in 2005 to that in 2012?
Offer a very short reply. 0.05. What is the ratio of the Imports(as % of merchandise exports) in Estonia in 2005 to that in 2012?
Keep it short and to the point. 0.59. What is the ratio of the Imports(as % of merchandise exports) in Panama in 2005 to that in 2012?
Offer a terse response. 4.78. What is the ratio of the Imports(as % of merchandise exports) of Dominica in 2006 to that in 2007?
Your response must be concise. 0.9. What is the ratio of the Imports(as % of merchandise exports) in Dominican Republic in 2006 to that in 2007?
Ensure brevity in your answer.  0.95. What is the ratio of the Imports(as % of merchandise exports) of Estonia in 2006 to that in 2007?
Your answer should be compact. 1.24. What is the ratio of the Imports(as % of merchandise exports) of Panama in 2006 to that in 2007?
Provide a succinct answer. 0.97. What is the ratio of the Imports(as % of merchandise exports) in Dominica in 2006 to that in 2008?
Provide a short and direct response. 0.99. What is the ratio of the Imports(as % of merchandise exports) of Estonia in 2006 to that in 2008?
Offer a terse response. 1.12. What is the ratio of the Imports(as % of merchandise exports) of Panama in 2006 to that in 2008?
Offer a very short reply. 1.97. What is the ratio of the Imports(as % of merchandise exports) of Dominica in 2006 to that in 2009?
Your response must be concise. 0.99. What is the ratio of the Imports(as % of merchandise exports) of Dominican Republic in 2006 to that in 2009?
Your response must be concise. 0.07. What is the ratio of the Imports(as % of merchandise exports) of Estonia in 2006 to that in 2009?
Make the answer very short. 0.95. What is the ratio of the Imports(as % of merchandise exports) in Panama in 2006 to that in 2009?
Make the answer very short. 3.98. What is the ratio of the Imports(as % of merchandise exports) of Dominica in 2006 to that in 2010?
Keep it short and to the point. 0.89. What is the ratio of the Imports(as % of merchandise exports) of Dominican Republic in 2006 to that in 2010?
Your answer should be very brief. 0.06. What is the ratio of the Imports(as % of merchandise exports) of Estonia in 2006 to that in 2010?
Your response must be concise. 1.09. What is the ratio of the Imports(as % of merchandise exports) in Panama in 2006 to that in 2010?
Ensure brevity in your answer.  4.42. What is the ratio of the Imports(as % of merchandise exports) of Dominica in 2006 to that in 2012?
Your answer should be very brief. 0.7. What is the ratio of the Imports(as % of merchandise exports) in Dominican Republic in 2006 to that in 2012?
Your answer should be very brief. 0.06. What is the ratio of the Imports(as % of merchandise exports) in Estonia in 2006 to that in 2012?
Your response must be concise. 1.03. What is the ratio of the Imports(as % of merchandise exports) in Panama in 2006 to that in 2012?
Offer a terse response. 1.76. What is the ratio of the Imports(as % of merchandise exports) of Dominica in 2007 to that in 2008?
Make the answer very short. 1.1. What is the ratio of the Imports(as % of merchandise exports) in Estonia in 2007 to that in 2008?
Offer a terse response. 0.91. What is the ratio of the Imports(as % of merchandise exports) of Panama in 2007 to that in 2008?
Keep it short and to the point. 2.04. What is the ratio of the Imports(as % of merchandise exports) in Dominica in 2007 to that in 2009?
Give a very brief answer. 1.1. What is the ratio of the Imports(as % of merchandise exports) of Dominican Republic in 2007 to that in 2009?
Ensure brevity in your answer.  0.08. What is the ratio of the Imports(as % of merchandise exports) of Estonia in 2007 to that in 2009?
Make the answer very short. 0.77. What is the ratio of the Imports(as % of merchandise exports) of Panama in 2007 to that in 2009?
Your answer should be compact. 4.11. What is the ratio of the Imports(as % of merchandise exports) in Dominica in 2007 to that in 2010?
Provide a succinct answer. 0.99. What is the ratio of the Imports(as % of merchandise exports) of Dominican Republic in 2007 to that in 2010?
Provide a short and direct response. 0.07. What is the ratio of the Imports(as % of merchandise exports) in Estonia in 2007 to that in 2010?
Keep it short and to the point. 0.88. What is the ratio of the Imports(as % of merchandise exports) of Panama in 2007 to that in 2010?
Give a very brief answer. 4.57. What is the ratio of the Imports(as % of merchandise exports) in Dominica in 2007 to that in 2012?
Keep it short and to the point. 0.78. What is the ratio of the Imports(as % of merchandise exports) of Dominican Republic in 2007 to that in 2012?
Your answer should be compact. 0.06. What is the ratio of the Imports(as % of merchandise exports) in Estonia in 2007 to that in 2012?
Offer a very short reply. 0.83. What is the ratio of the Imports(as % of merchandise exports) of Panama in 2007 to that in 2012?
Your response must be concise. 1.82. What is the ratio of the Imports(as % of merchandise exports) in Dominica in 2008 to that in 2009?
Offer a terse response. 1. What is the ratio of the Imports(as % of merchandise exports) in Dominican Republic in 2008 to that in 2009?
Provide a short and direct response. 0.07. What is the ratio of the Imports(as % of merchandise exports) in Estonia in 2008 to that in 2009?
Offer a very short reply. 0.85. What is the ratio of the Imports(as % of merchandise exports) of Panama in 2008 to that in 2009?
Provide a short and direct response. 2.02. What is the ratio of the Imports(as % of merchandise exports) of Dominica in 2008 to that in 2010?
Your answer should be very brief. 0.9. What is the ratio of the Imports(as % of merchandise exports) in Dominican Republic in 2008 to that in 2010?
Provide a succinct answer. 0.06. What is the ratio of the Imports(as % of merchandise exports) in Estonia in 2008 to that in 2010?
Your answer should be very brief. 0.97. What is the ratio of the Imports(as % of merchandise exports) in Panama in 2008 to that in 2010?
Your answer should be very brief. 2.24. What is the ratio of the Imports(as % of merchandise exports) in Dominica in 2008 to that in 2012?
Make the answer very short. 0.71. What is the ratio of the Imports(as % of merchandise exports) of Dominican Republic in 2008 to that in 2012?
Offer a terse response. 0.06. What is the ratio of the Imports(as % of merchandise exports) in Estonia in 2008 to that in 2012?
Offer a terse response. 0.91. What is the ratio of the Imports(as % of merchandise exports) in Panama in 2008 to that in 2012?
Make the answer very short. 0.89. What is the ratio of the Imports(as % of merchandise exports) in Dominica in 2009 to that in 2010?
Give a very brief answer. 0.9. What is the ratio of the Imports(as % of merchandise exports) in Dominican Republic in 2009 to that in 2010?
Keep it short and to the point. 0.86. What is the ratio of the Imports(as % of merchandise exports) in Estonia in 2009 to that in 2010?
Keep it short and to the point. 1.14. What is the ratio of the Imports(as % of merchandise exports) of Panama in 2009 to that in 2010?
Offer a terse response. 1.11. What is the ratio of the Imports(as % of merchandise exports) of Dominica in 2009 to that in 2012?
Provide a short and direct response. 0.71. What is the ratio of the Imports(as % of merchandise exports) in Dominican Republic in 2009 to that in 2012?
Ensure brevity in your answer.  0.83. What is the ratio of the Imports(as % of merchandise exports) in Estonia in 2009 to that in 2012?
Make the answer very short. 1.08. What is the ratio of the Imports(as % of merchandise exports) of Panama in 2009 to that in 2012?
Your answer should be compact. 0.44. What is the ratio of the Imports(as % of merchandise exports) of Dominica in 2010 to that in 2012?
Ensure brevity in your answer.  0.78. What is the ratio of the Imports(as % of merchandise exports) in Dominican Republic in 2010 to that in 2012?
Your response must be concise. 0.97. What is the ratio of the Imports(as % of merchandise exports) in Estonia in 2010 to that in 2012?
Make the answer very short. 0.94. What is the ratio of the Imports(as % of merchandise exports) in Panama in 2010 to that in 2012?
Provide a short and direct response. 0.4. What is the difference between the highest and the second highest Imports(as % of merchandise exports) in Dominica?
Offer a very short reply. 4.84. What is the difference between the highest and the second highest Imports(as % of merchandise exports) of Dominican Republic?
Offer a very short reply. 0.81. What is the difference between the highest and the second highest Imports(as % of merchandise exports) in Estonia?
Your answer should be compact. 0.84. What is the difference between the highest and the second highest Imports(as % of merchandise exports) in Panama?
Provide a short and direct response. 11.13. What is the difference between the highest and the lowest Imports(as % of merchandise exports) of Dominica?
Provide a short and direct response. 8.89. What is the difference between the highest and the lowest Imports(as % of merchandise exports) in Dominican Republic?
Make the answer very short. 24.1. What is the difference between the highest and the lowest Imports(as % of merchandise exports) of Estonia?
Offer a terse response. 8.39. What is the difference between the highest and the lowest Imports(as % of merchandise exports) in Panama?
Your response must be concise. 16.45. 